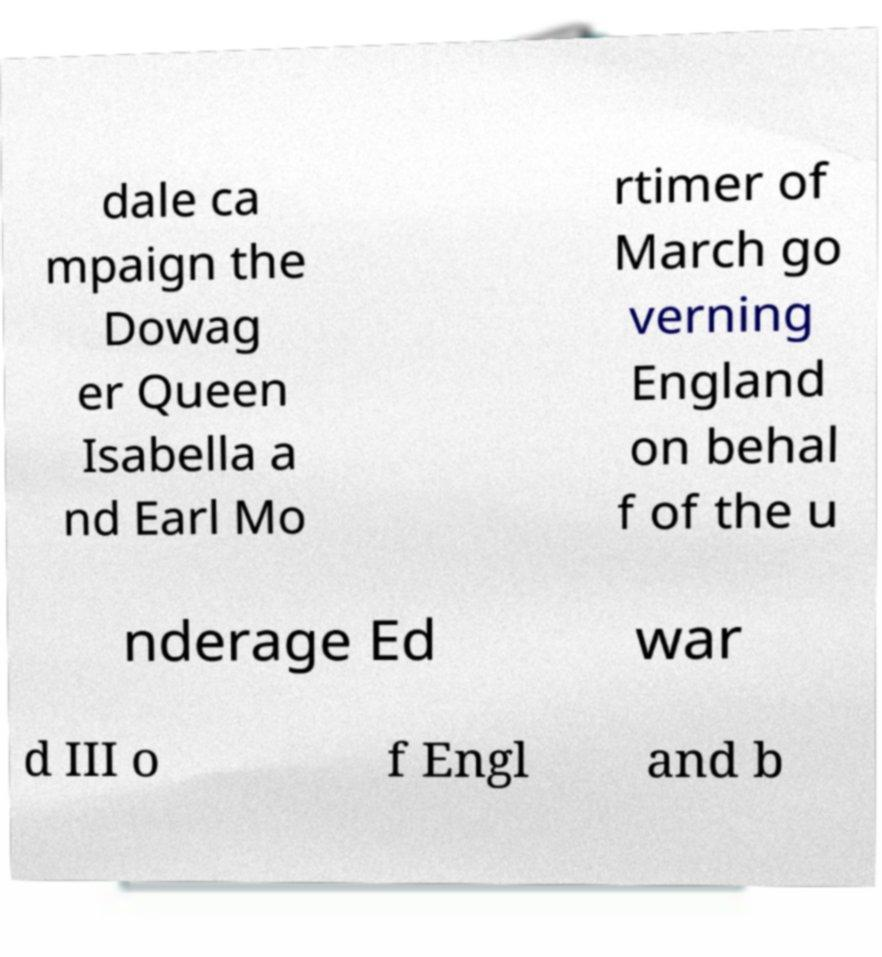Can you accurately transcribe the text from the provided image for me? dale ca mpaign the Dowag er Queen Isabella a nd Earl Mo rtimer of March go verning England on behal f of the u nderage Ed war d III o f Engl and b 